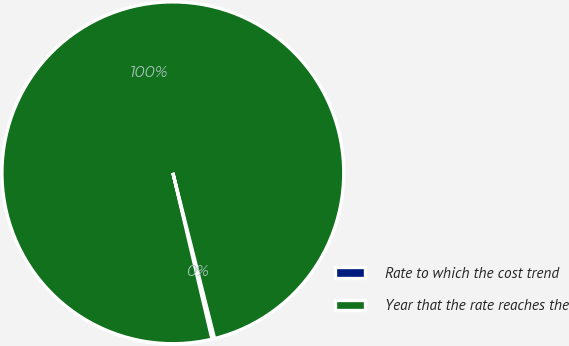Convert chart to OTSL. <chart><loc_0><loc_0><loc_500><loc_500><pie_chart><fcel>Rate to which the cost trend<fcel>Year that the rate reaches the<nl><fcel>0.25%<fcel>99.75%<nl></chart> 